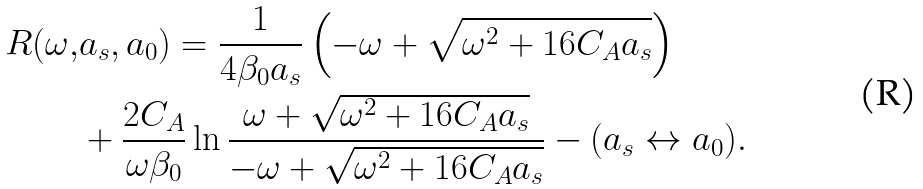<formula> <loc_0><loc_0><loc_500><loc_500>R ( \omega , & a _ { s } , a _ { 0 } ) = \frac { 1 } { 4 \beta _ { 0 } a _ { s } } \left ( - \omega + \sqrt { \omega ^ { 2 } + 1 6 C _ { A } a _ { s } } \right ) \\ & + \frac { 2 C _ { A } } { \omega \beta _ { 0 } } \ln \frac { \omega + \sqrt { \omega ^ { 2 } + 1 6 C _ { A } a _ { s } } } { - \omega + \sqrt { \omega ^ { 2 } + 1 6 C _ { A } a _ { s } } } - ( a _ { s } \leftrightarrow a _ { 0 } ) .</formula> 